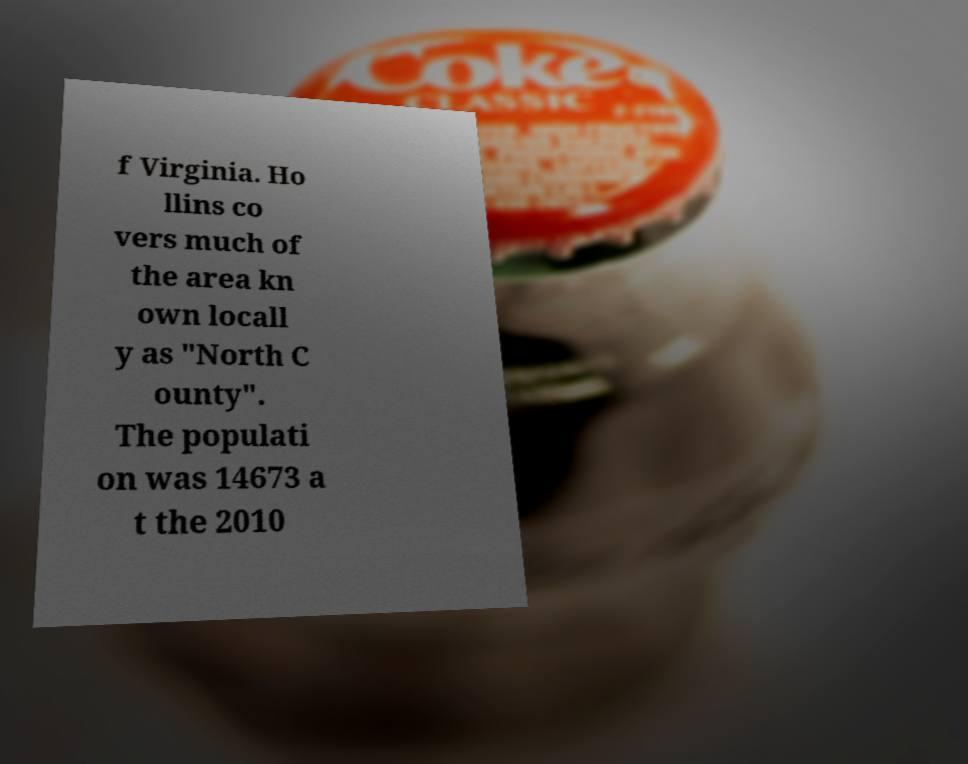Can you read and provide the text displayed in the image?This photo seems to have some interesting text. Can you extract and type it out for me? f Virginia. Ho llins co vers much of the area kn own locall y as "North C ounty". The populati on was 14673 a t the 2010 